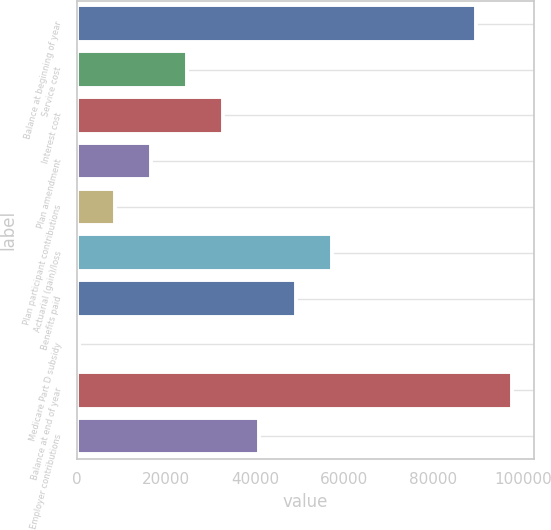<chart> <loc_0><loc_0><loc_500><loc_500><bar_chart><fcel>Balance at beginning of year<fcel>Service cost<fcel>Interest cost<fcel>Plan amendment<fcel>Plan participant contributions<fcel>Actuarial (gain)/loss<fcel>Benefits paid<fcel>Medicare Part D subsidy<fcel>Balance at end of year<fcel>Employer contributions<nl><fcel>89568.4<fcel>24733.2<fcel>32837.6<fcel>16628.8<fcel>8524.4<fcel>57150.8<fcel>49046.4<fcel>420<fcel>97672.8<fcel>40942<nl></chart> 